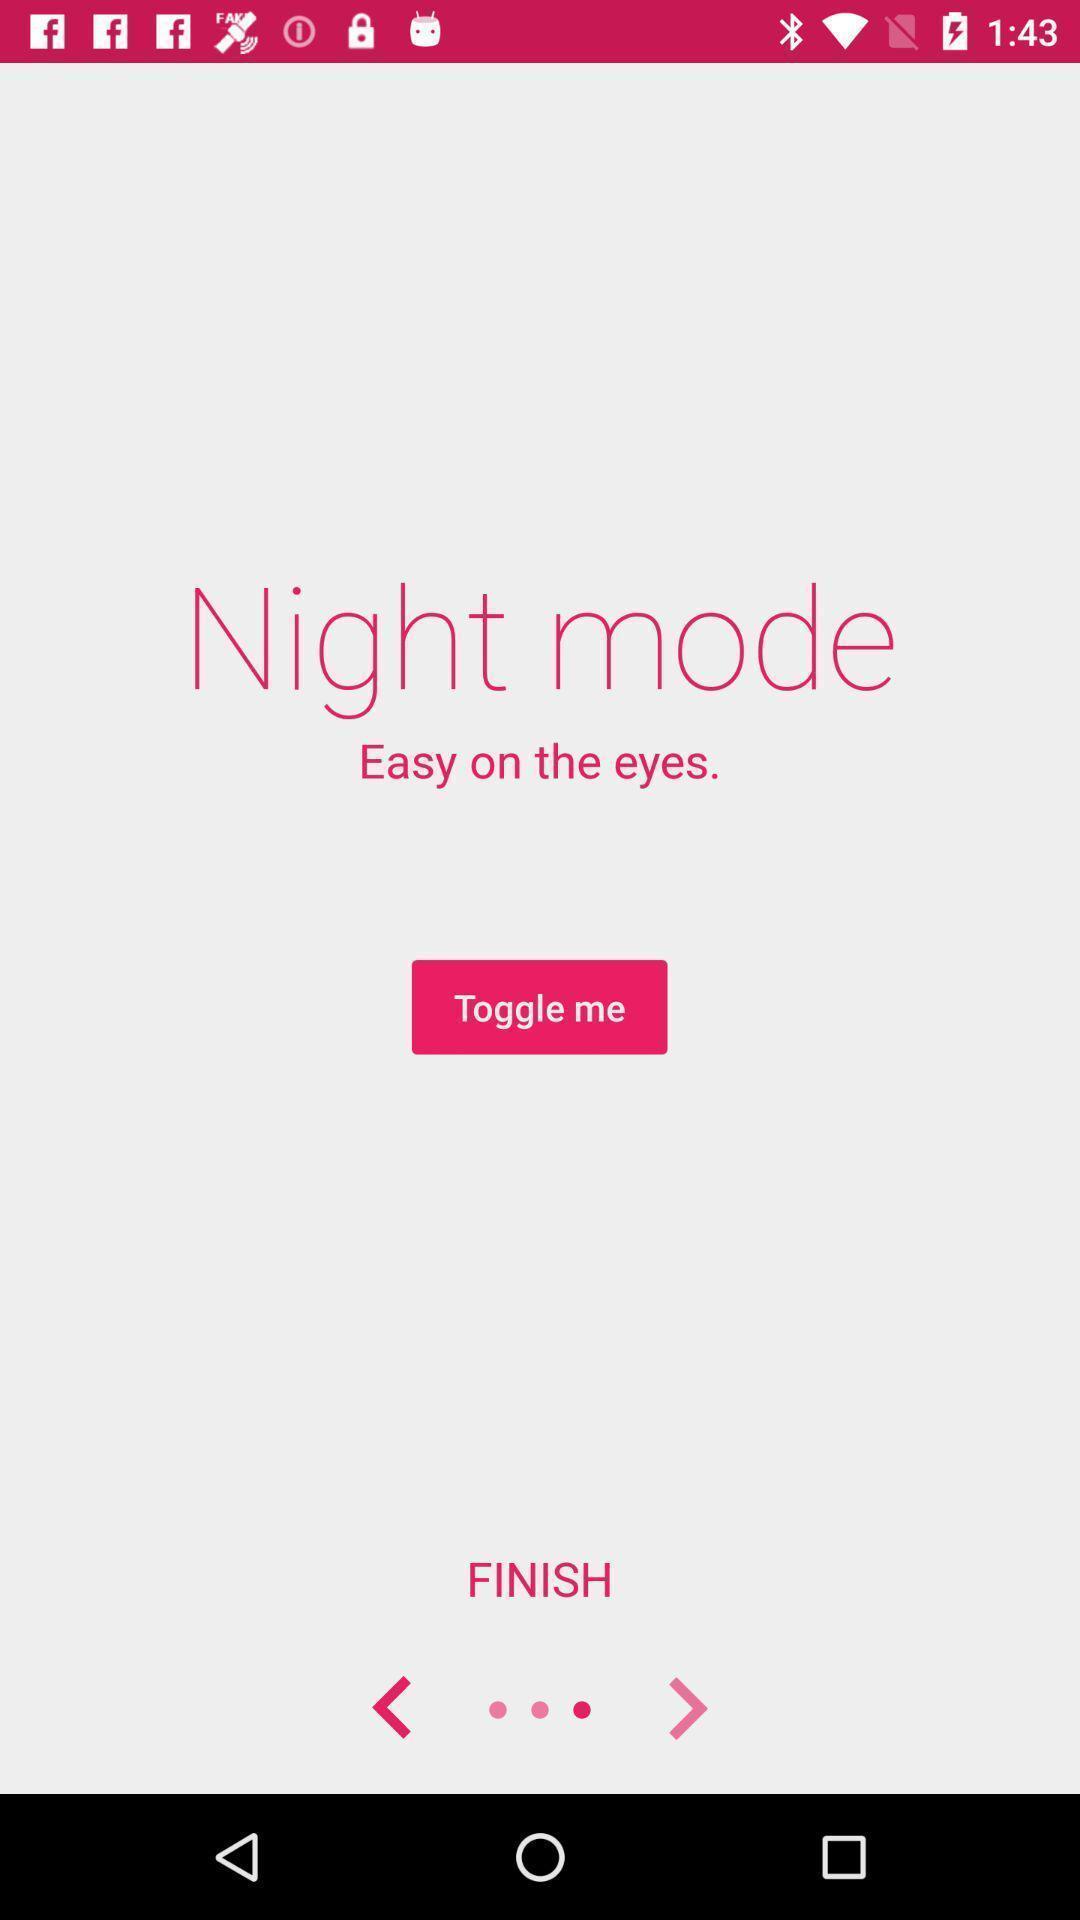What is the overall content of this screenshot? Screen page of a night mode in a social app. 